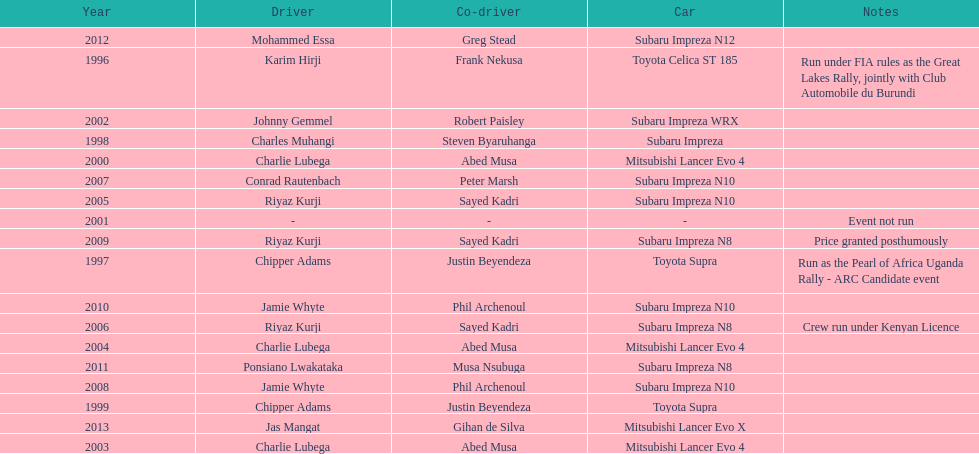How many drivers won at least twice? 4. 